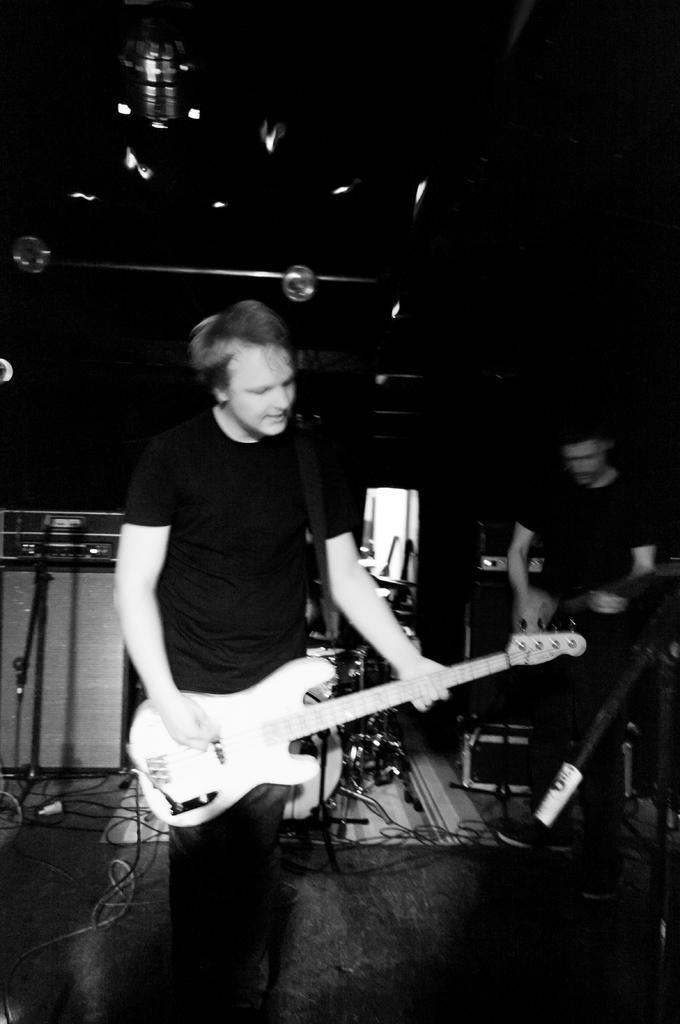Could you give a brief overview of what you see in this image? In this picture there is a man standing and playing a guitar , and the back ground there is another man standing and playing the guitar. 